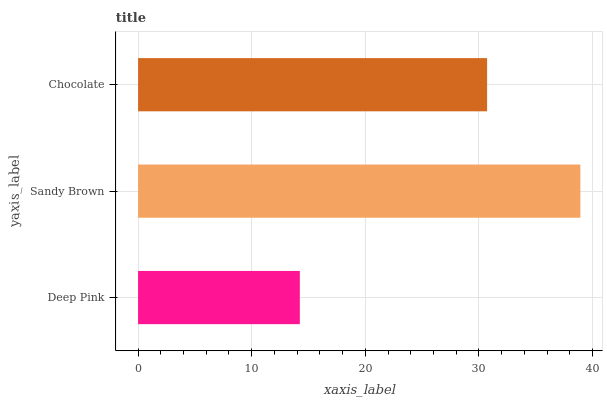Is Deep Pink the minimum?
Answer yes or no. Yes. Is Sandy Brown the maximum?
Answer yes or no. Yes. Is Chocolate the minimum?
Answer yes or no. No. Is Chocolate the maximum?
Answer yes or no. No. Is Sandy Brown greater than Chocolate?
Answer yes or no. Yes. Is Chocolate less than Sandy Brown?
Answer yes or no. Yes. Is Chocolate greater than Sandy Brown?
Answer yes or no. No. Is Sandy Brown less than Chocolate?
Answer yes or no. No. Is Chocolate the high median?
Answer yes or no. Yes. Is Chocolate the low median?
Answer yes or no. Yes. Is Deep Pink the high median?
Answer yes or no. No. Is Sandy Brown the low median?
Answer yes or no. No. 